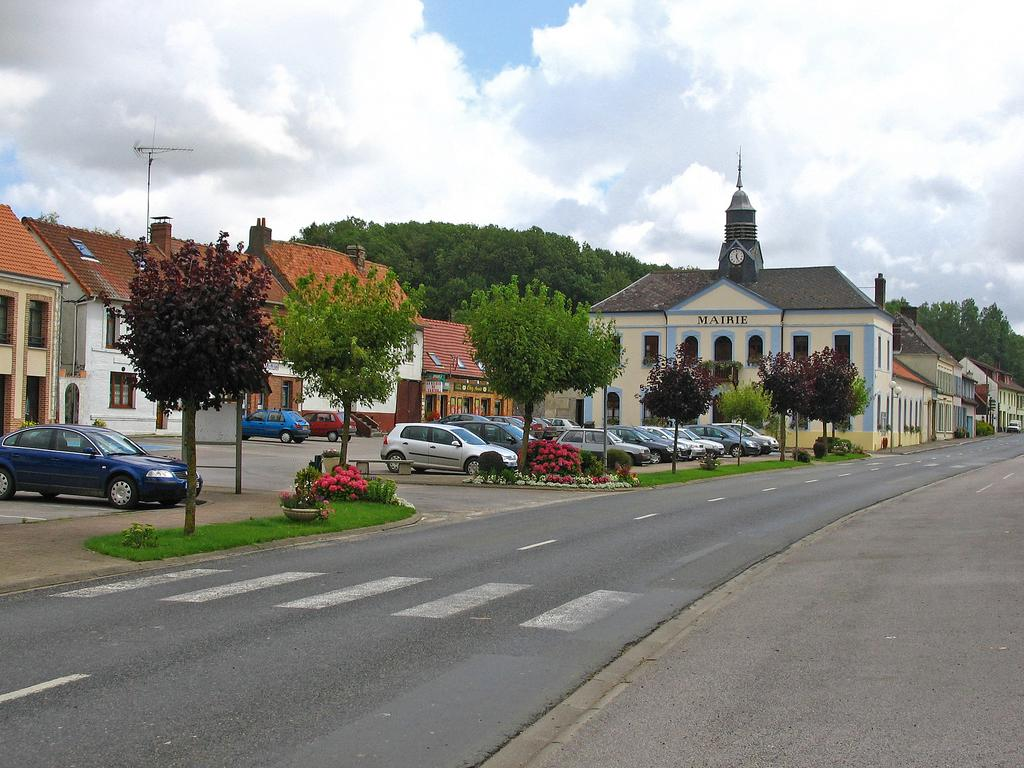What type of structures can be seen in the image? There are buildings in the image. What is located in front of the buildings? Cars are present in front of the buildings. What type of vegetation is visible in the image? Flowers, trees, and grass are visible in the image. What is visible in the background of the image? The sky is visible in the background of the image. What type of bottle can be seen hanging from the tree in the image? There is no bottle present in the image, and no bottle is hanging from any tree. 